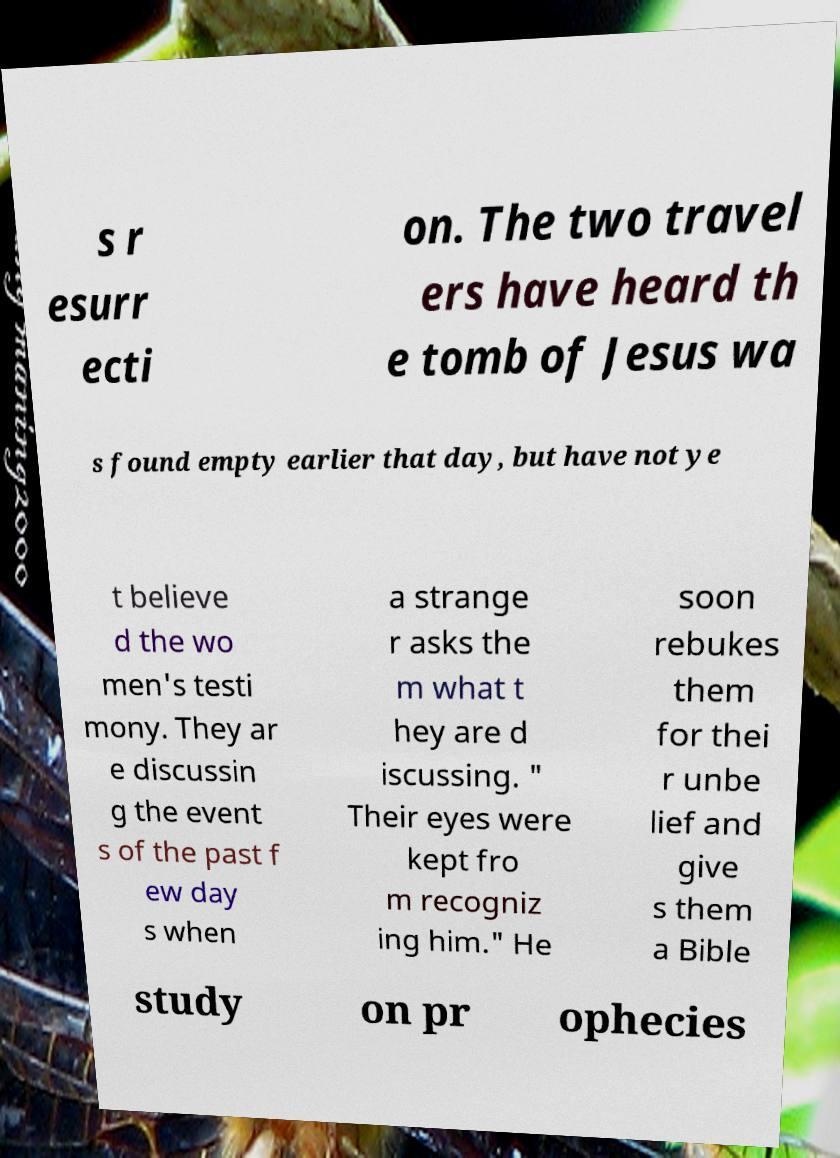I need the written content from this picture converted into text. Can you do that? s r esurr ecti on. The two travel ers have heard th e tomb of Jesus wa s found empty earlier that day, but have not ye t believe d the wo men's testi mony. They ar e discussin g the event s of the past f ew day s when a strange r asks the m what t hey are d iscussing. " Their eyes were kept fro m recogniz ing him." He soon rebukes them for thei r unbe lief and give s them a Bible study on pr ophecies 